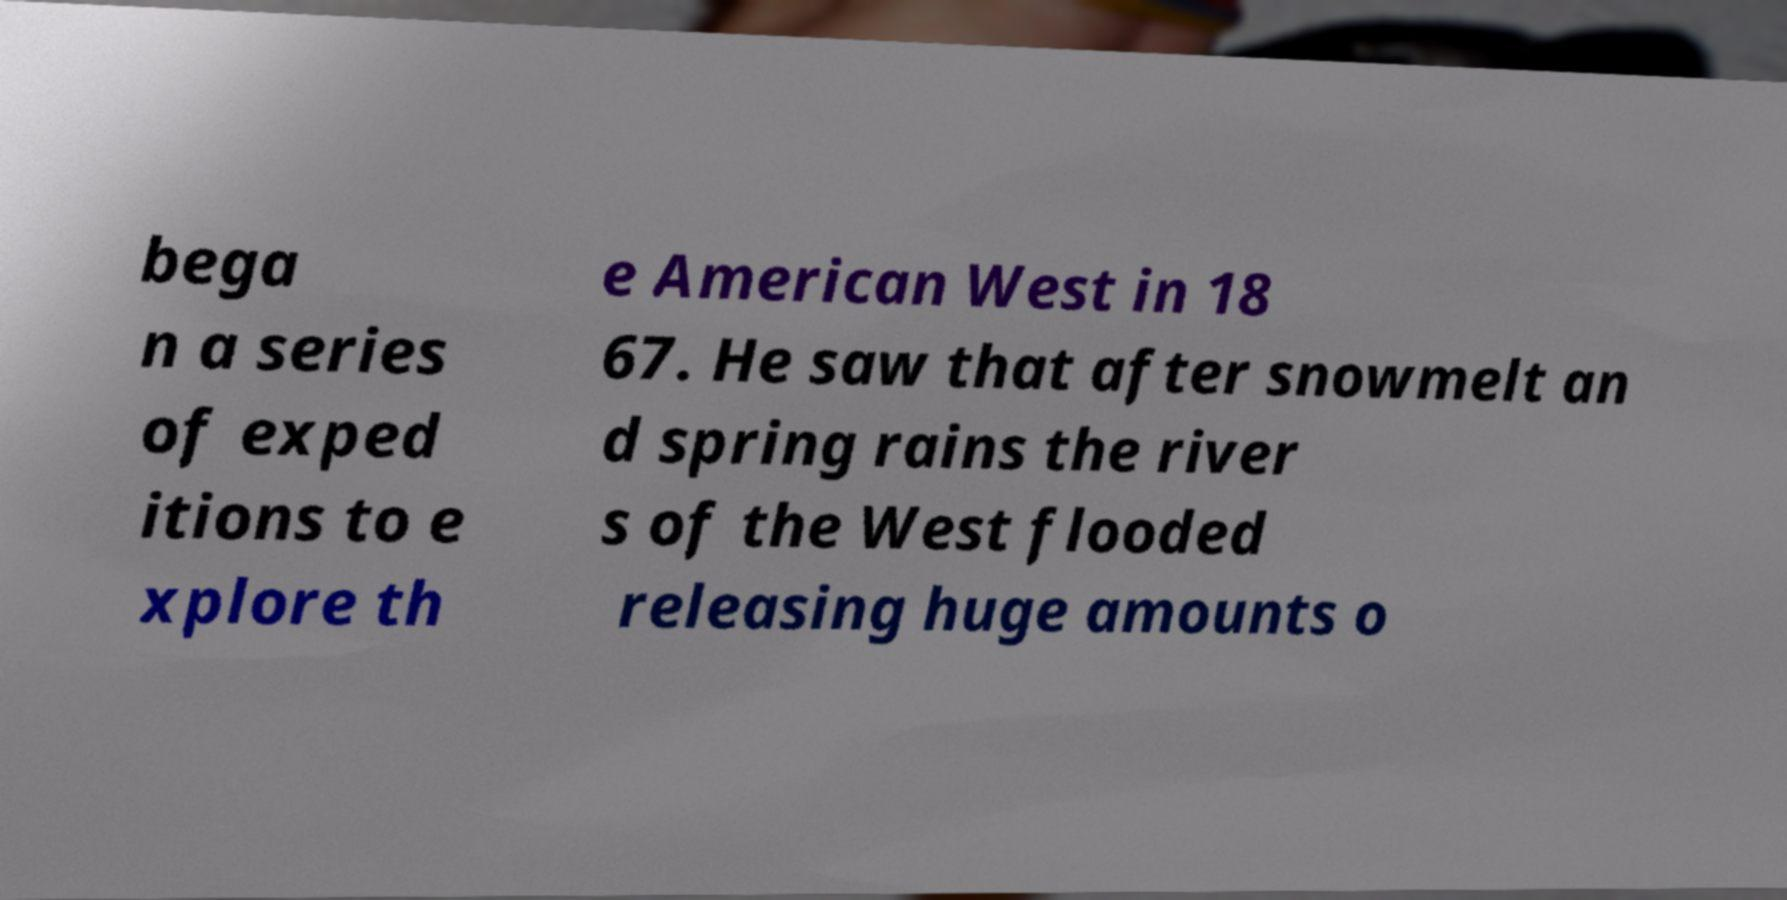For documentation purposes, I need the text within this image transcribed. Could you provide that? bega n a series of exped itions to e xplore th e American West in 18 67. He saw that after snowmelt an d spring rains the river s of the West flooded releasing huge amounts o 